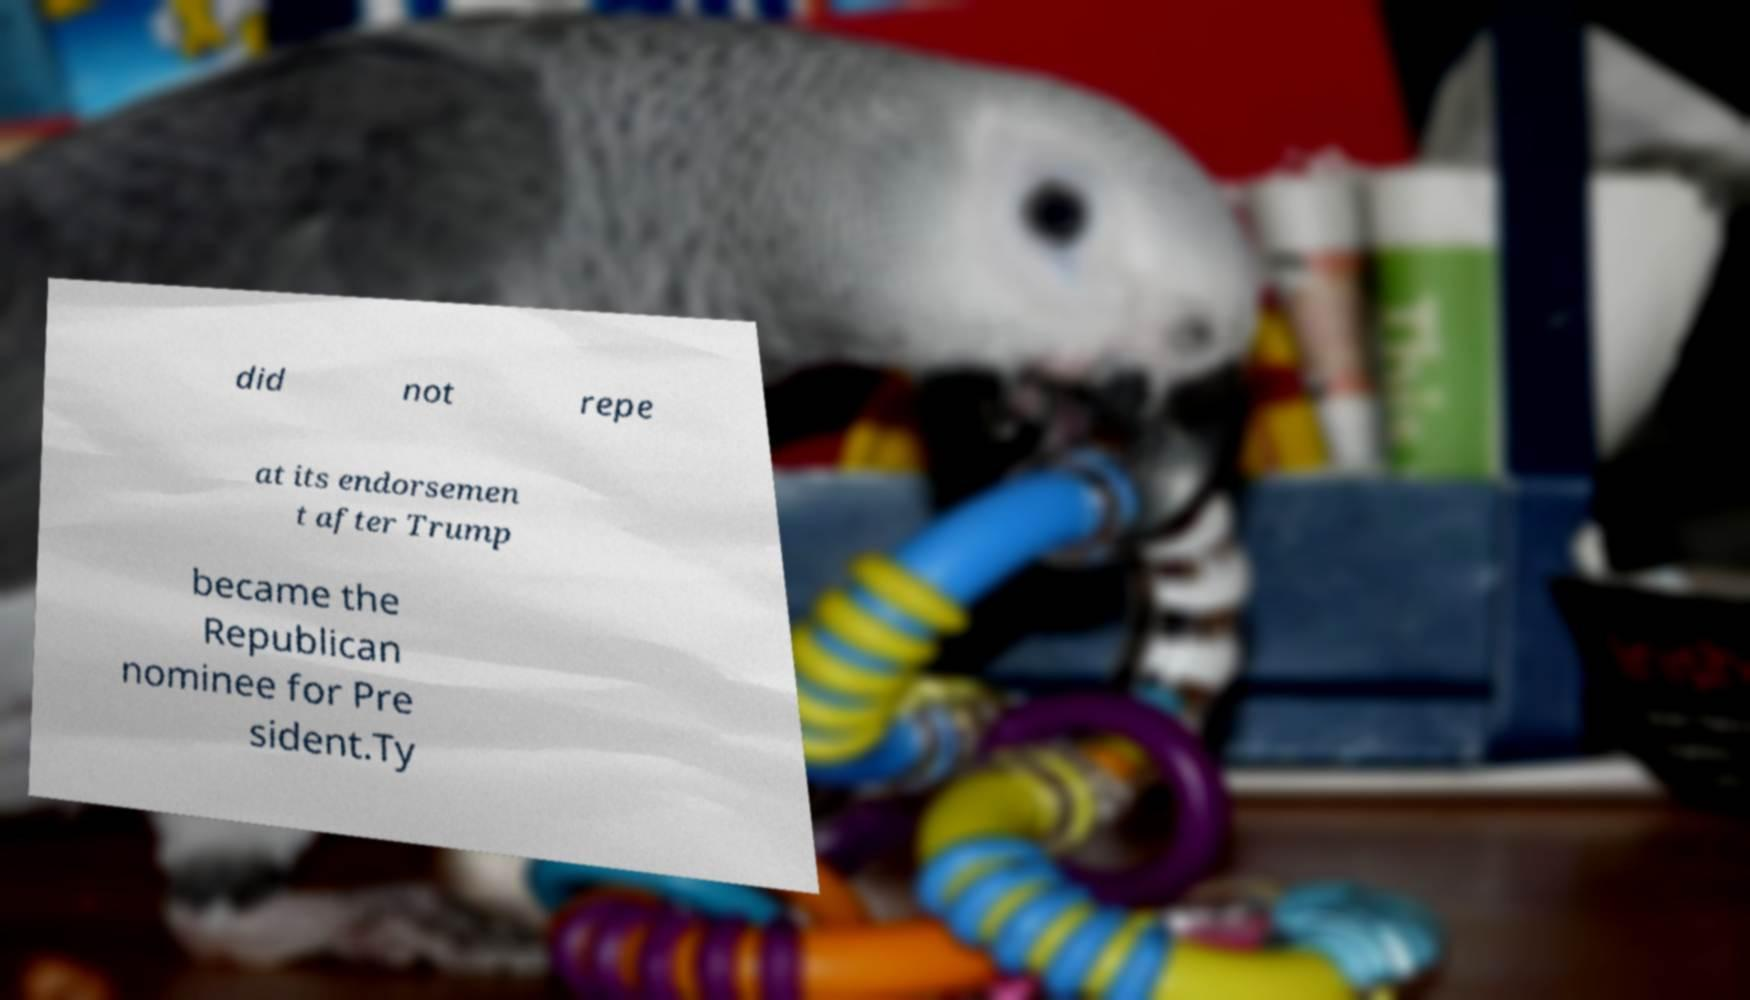There's text embedded in this image that I need extracted. Can you transcribe it verbatim? did not repe at its endorsemen t after Trump became the Republican nominee for Pre sident.Ty 